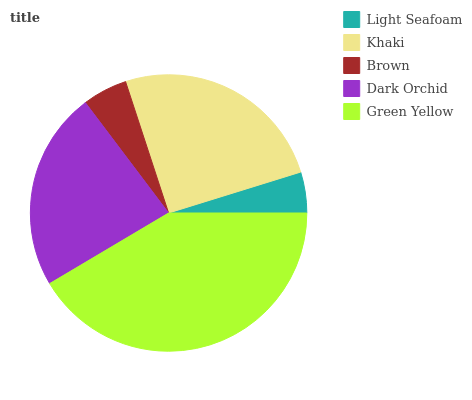Is Light Seafoam the minimum?
Answer yes or no. Yes. Is Green Yellow the maximum?
Answer yes or no. Yes. Is Khaki the minimum?
Answer yes or no. No. Is Khaki the maximum?
Answer yes or no. No. Is Khaki greater than Light Seafoam?
Answer yes or no. Yes. Is Light Seafoam less than Khaki?
Answer yes or no. Yes. Is Light Seafoam greater than Khaki?
Answer yes or no. No. Is Khaki less than Light Seafoam?
Answer yes or no. No. Is Dark Orchid the high median?
Answer yes or no. Yes. Is Dark Orchid the low median?
Answer yes or no. Yes. Is Green Yellow the high median?
Answer yes or no. No. Is Light Seafoam the low median?
Answer yes or no. No. 